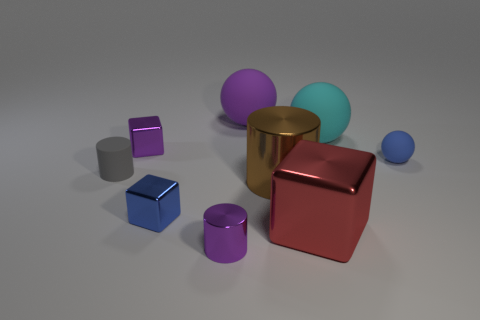There is a thing that is on the left side of the big block and in front of the blue block; what is it made of?
Ensure brevity in your answer.  Metal. What is the material of the cylinder that is the same size as the cyan object?
Ensure brevity in your answer.  Metal. How big is the purple shiny thing that is in front of the blue object in front of the matte thing that is right of the big cyan rubber thing?
Offer a very short reply. Small. There is a purple sphere that is made of the same material as the big cyan thing; what is its size?
Give a very brief answer. Large. Does the cyan ball have the same size as the purple object on the right side of the purple cylinder?
Your answer should be very brief. Yes. There is a small purple metallic thing that is behind the big red metal object; what is its shape?
Ensure brevity in your answer.  Cube. There is a tiny blue thing to the left of the purple thing in front of the red thing; is there a tiny block on the right side of it?
Ensure brevity in your answer.  No. What is the material of the blue thing that is the same shape as the big red object?
Your answer should be very brief. Metal. Is there any other thing that has the same material as the brown object?
Keep it short and to the point. Yes. What number of spheres are blue things or large cyan things?
Offer a terse response. 2. 